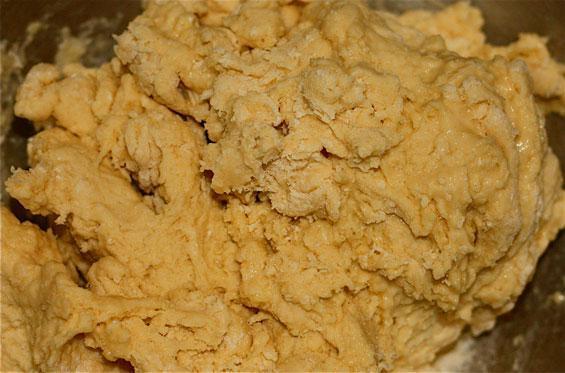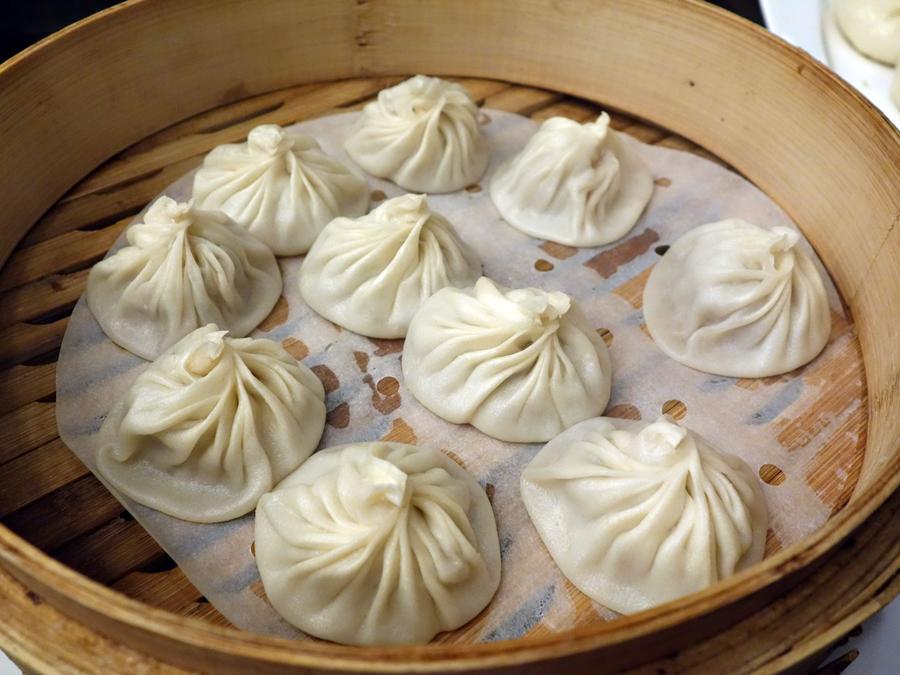The first image is the image on the left, the second image is the image on the right. Examine the images to the left and right. Is the description "Noodles are in a pile on a wood-grain board in one image, and the other image includes raw eggs in the center of white flour in a bowl." accurate? Answer yes or no. No. The first image is the image on the left, the second image is the image on the right. For the images displayed, is the sentence "One photo shows clearly visible eggs being used as an ingredient and the other image shows completed homemade noodles." factually correct? Answer yes or no. No. 